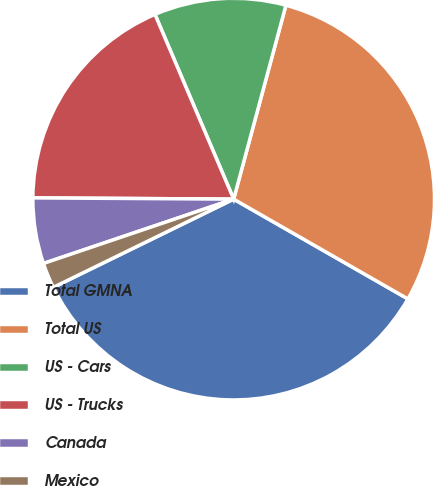Convert chart to OTSL. <chart><loc_0><loc_0><loc_500><loc_500><pie_chart><fcel>Total GMNA<fcel>Total US<fcel>US - Cars<fcel>US - Trucks<fcel>Canada<fcel>Mexico<nl><fcel>34.48%<fcel>29.09%<fcel>10.6%<fcel>18.49%<fcel>5.29%<fcel>2.05%<nl></chart> 